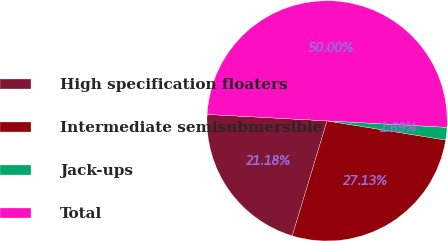Convert chart to OTSL. <chart><loc_0><loc_0><loc_500><loc_500><pie_chart><fcel>High specification floaters<fcel>Intermediate semisubmersible<fcel>Jack-ups<fcel>Total<nl><fcel>21.18%<fcel>27.13%<fcel>1.69%<fcel>50.0%<nl></chart> 